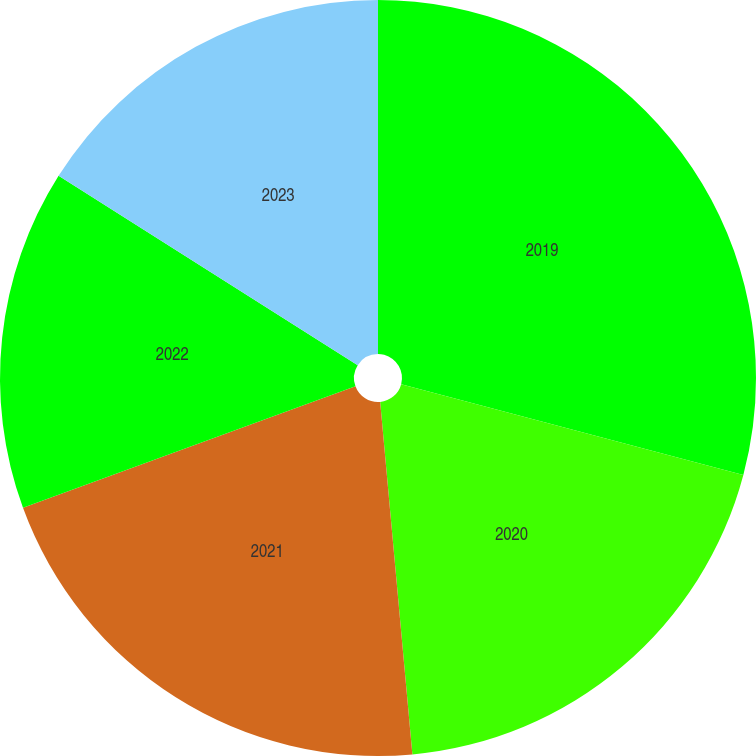Convert chart to OTSL. <chart><loc_0><loc_0><loc_500><loc_500><pie_chart><fcel>2019<fcel>2020<fcel>2021<fcel>2022<fcel>2023<nl><fcel>29.13%<fcel>19.42%<fcel>20.87%<fcel>14.56%<fcel>16.02%<nl></chart> 